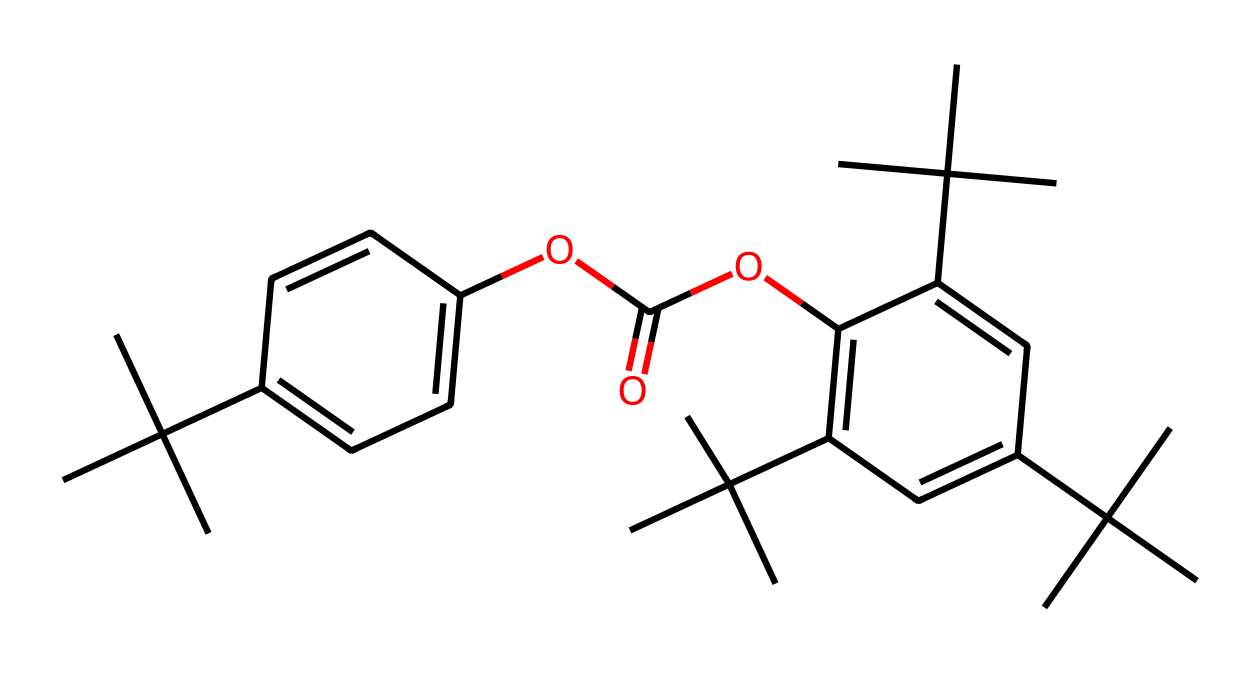What is the total number of carbon atoms in the molecular structure? By examining the SMILES representation, we can count the number of carbon (C) symbols. In this case, there are 36 carbon atoms present in the entire structure.
Answer: 36 How many benzene rings are present in the chemical structure? A benzene ring is indicated by a series of alternating double bonds or can be recognized by the 'C' atoms in a hexagonal arrangement. Upon analysis, there are 3 distinct benzene rings in this compound.
Answer: 3 What functional groups are present in this molecule? Looking at the structure, we identify the presence of an ester group (-OC(=O)-) and some alcohol groups due to the 'C(C)(C)' mentions. This indicates that the molecule likely contains an ester functionality and is used for polycarbonate formation.
Answer: ester Which group contributes to the impact resistance of polycarbonate? The presence of carbonate groups contributes to the durability and impact resistance of polycarbonate. Notably, the repeating carbonate linkages in the structure provide strength and resilience.
Answer: carbonate Is this a linear or branched polymer structure? The structure indicates that there are multiple branched carbon atoms connected to the main backbone, which is characteristic of a branched polymer. The notation '(C)(C)' indicates branching at carbon locations.
Answer: branched 